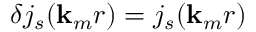<formula> <loc_0><loc_0><loc_500><loc_500>\delta j _ { s } ( { k } _ { m } r ) = j _ { s } ( { k } _ { m } r )</formula> 